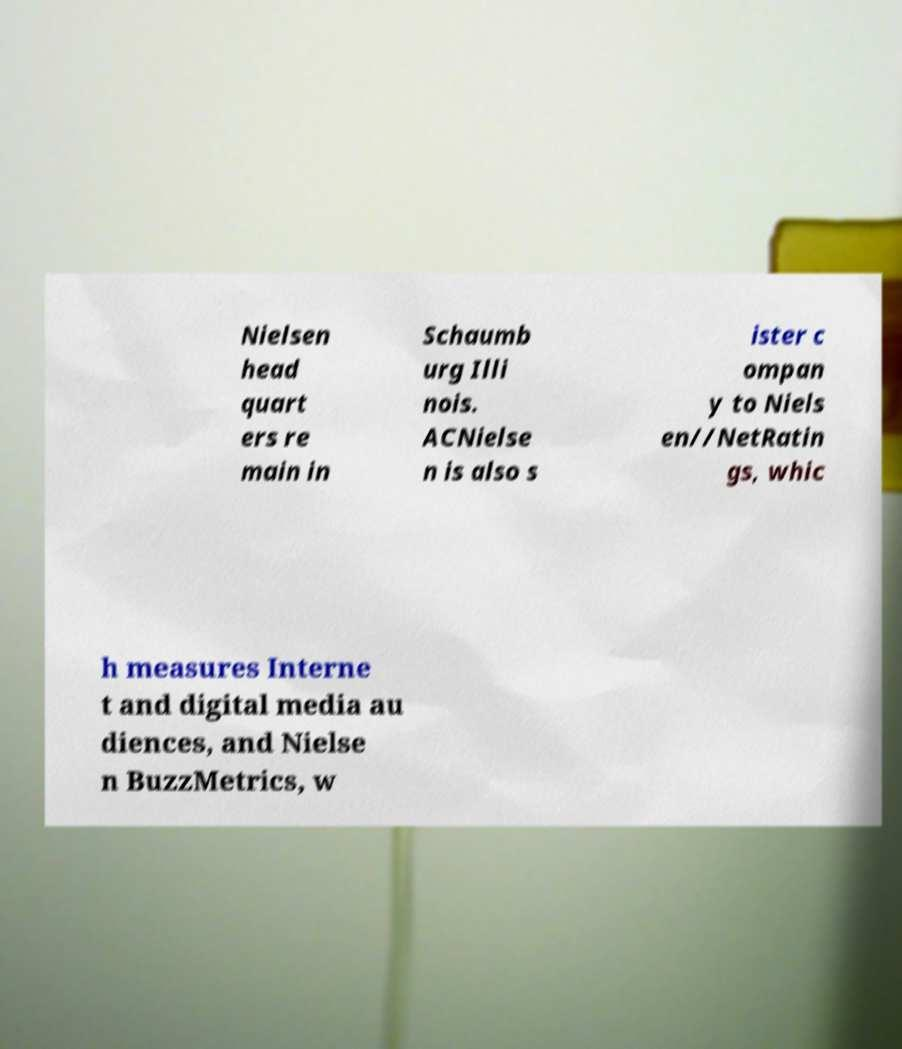For documentation purposes, I need the text within this image transcribed. Could you provide that? Nielsen head quart ers re main in Schaumb urg Illi nois. ACNielse n is also s ister c ompan y to Niels en//NetRatin gs, whic h measures Interne t and digital media au diences, and Nielse n BuzzMetrics, w 